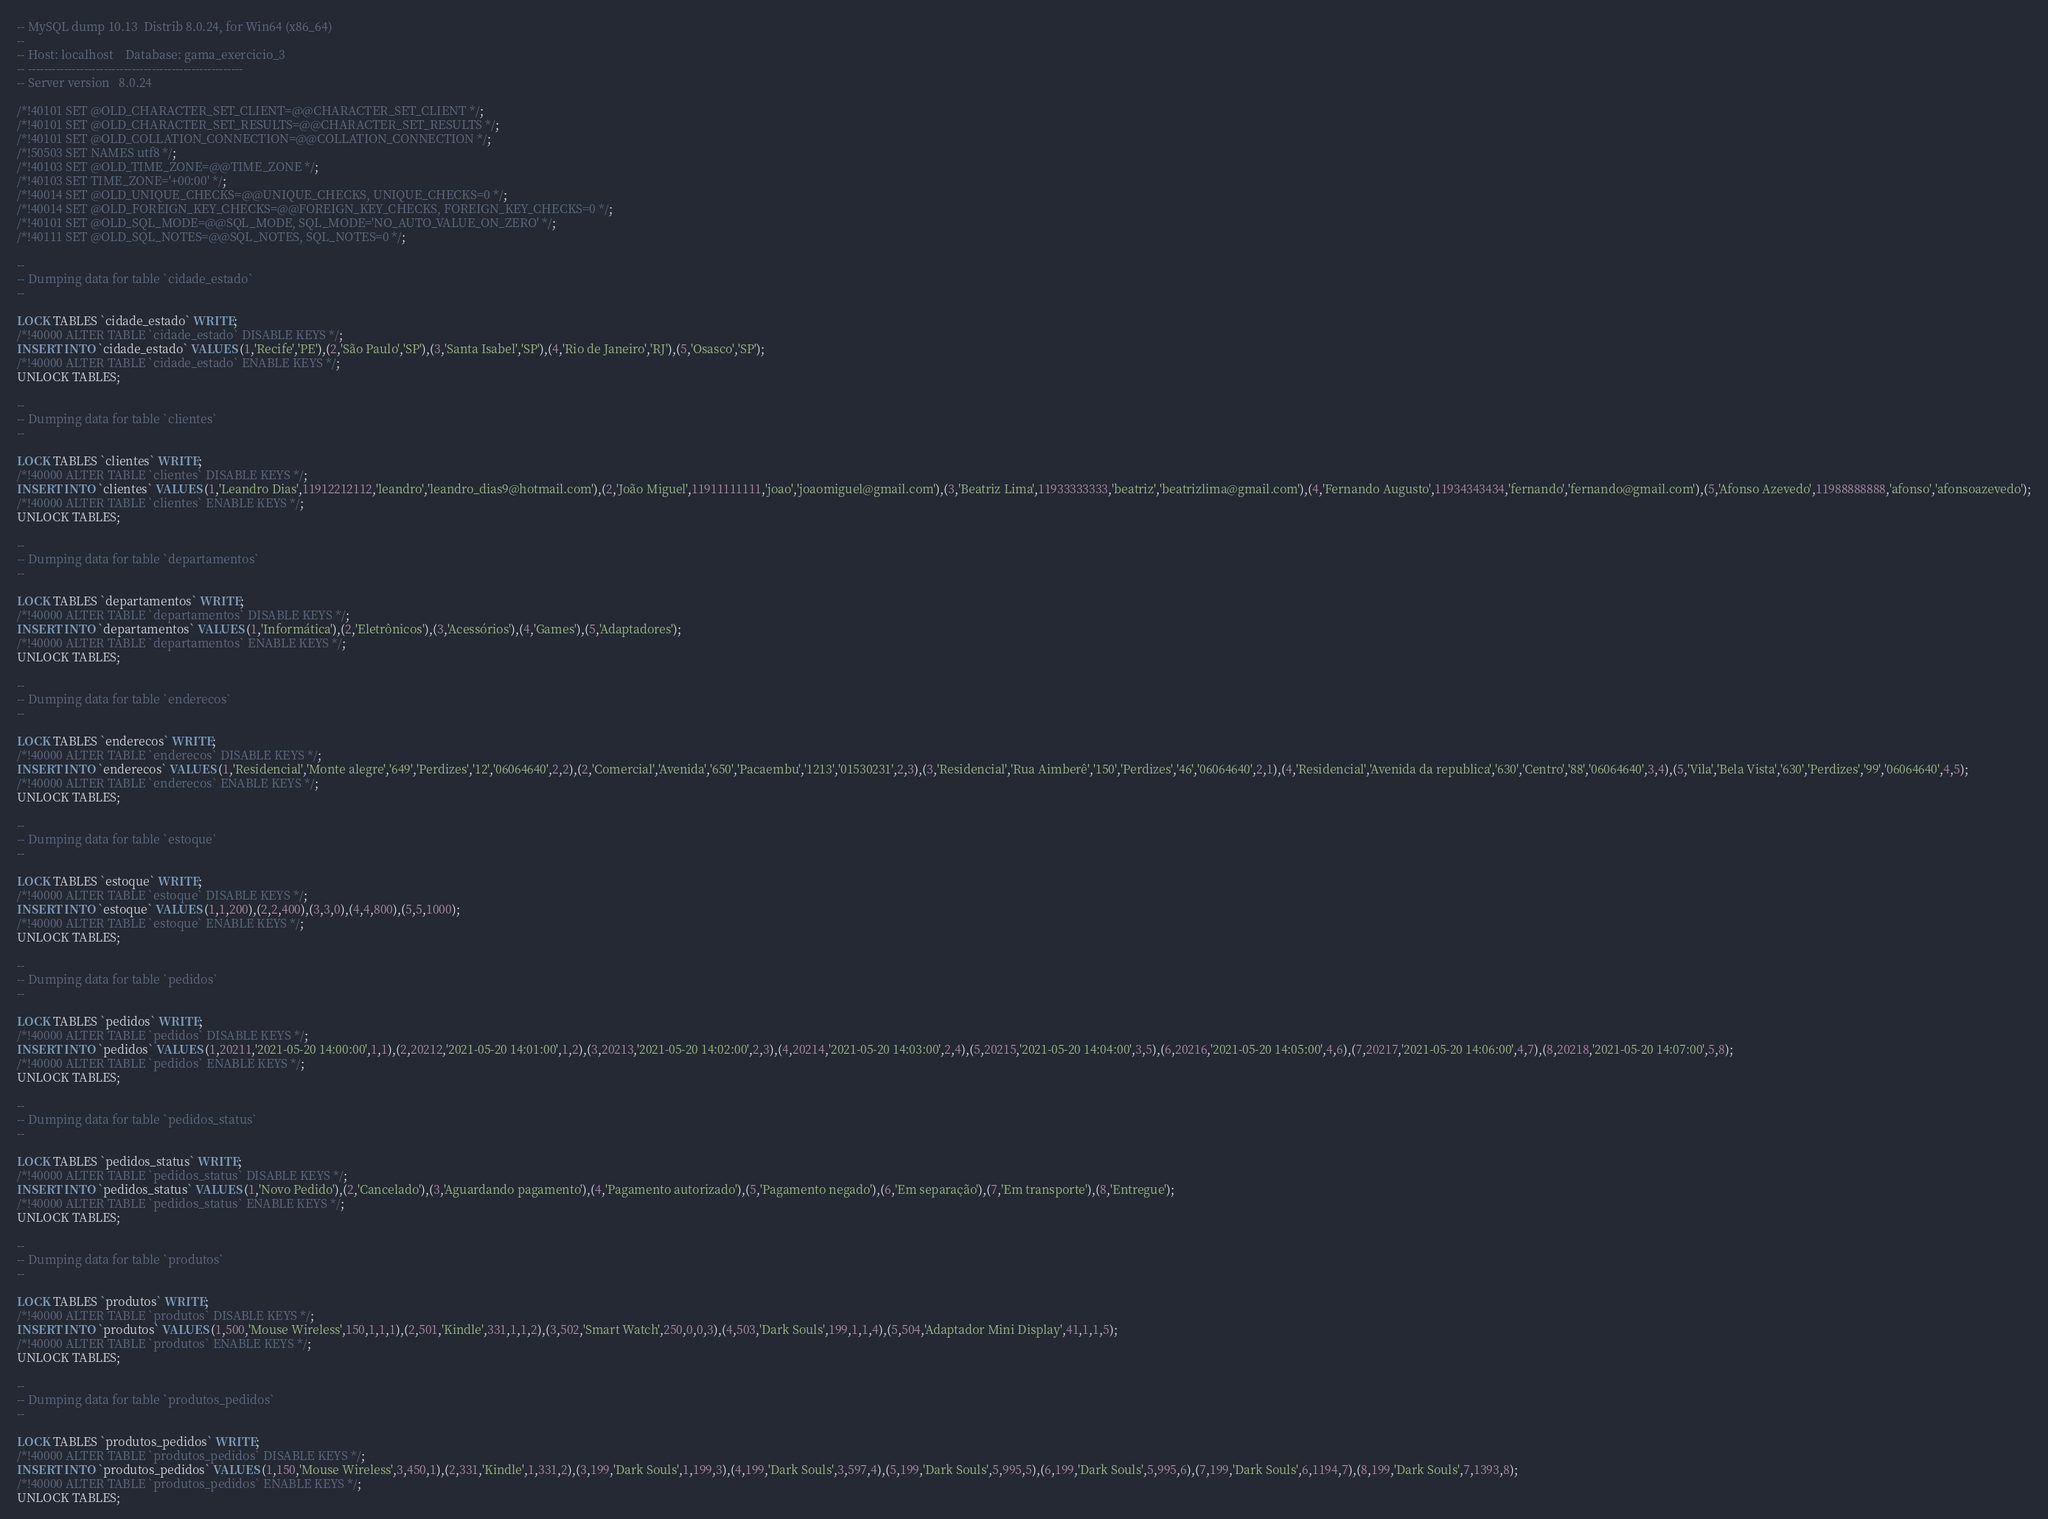<code> <loc_0><loc_0><loc_500><loc_500><_SQL_>-- MySQL dump 10.13  Distrib 8.0.24, for Win64 (x86_64)
--
-- Host: localhost    Database: gama_exercicio_3
-- ------------------------------------------------------
-- Server version	8.0.24

/*!40101 SET @OLD_CHARACTER_SET_CLIENT=@@CHARACTER_SET_CLIENT */;
/*!40101 SET @OLD_CHARACTER_SET_RESULTS=@@CHARACTER_SET_RESULTS */;
/*!40101 SET @OLD_COLLATION_CONNECTION=@@COLLATION_CONNECTION */;
/*!50503 SET NAMES utf8 */;
/*!40103 SET @OLD_TIME_ZONE=@@TIME_ZONE */;
/*!40103 SET TIME_ZONE='+00:00' */;
/*!40014 SET @OLD_UNIQUE_CHECKS=@@UNIQUE_CHECKS, UNIQUE_CHECKS=0 */;
/*!40014 SET @OLD_FOREIGN_KEY_CHECKS=@@FOREIGN_KEY_CHECKS, FOREIGN_KEY_CHECKS=0 */;
/*!40101 SET @OLD_SQL_MODE=@@SQL_MODE, SQL_MODE='NO_AUTO_VALUE_ON_ZERO' */;
/*!40111 SET @OLD_SQL_NOTES=@@SQL_NOTES, SQL_NOTES=0 */;

--
-- Dumping data for table `cidade_estado`
--

LOCK TABLES `cidade_estado` WRITE;
/*!40000 ALTER TABLE `cidade_estado` DISABLE KEYS */;
INSERT INTO `cidade_estado` VALUES (1,'Recife','PE'),(2,'São Paulo','SP'),(3,'Santa Isabel','SP'),(4,'Rio de Janeiro','RJ'),(5,'Osasco','SP');
/*!40000 ALTER TABLE `cidade_estado` ENABLE KEYS */;
UNLOCK TABLES;

--
-- Dumping data for table `clientes`
--

LOCK TABLES `clientes` WRITE;
/*!40000 ALTER TABLE `clientes` DISABLE KEYS */;
INSERT INTO `clientes` VALUES (1,'Leandro Dias',11912212112,'leandro','leandro_dias9@hotmail.com'),(2,'João Miguel',11911111111,'joao','joaomiguel@gmail.com'),(3,'Beatriz Lima',11933333333,'beatriz','beatrizlima@gmail.com'),(4,'Fernando Augusto',11934343434,'fernando','fernando@gmail.com'),(5,'Afonso Azevedo',11988888888,'afonso','afonsoazevedo');
/*!40000 ALTER TABLE `clientes` ENABLE KEYS */;
UNLOCK TABLES;

--
-- Dumping data for table `departamentos`
--

LOCK TABLES `departamentos` WRITE;
/*!40000 ALTER TABLE `departamentos` DISABLE KEYS */;
INSERT INTO `departamentos` VALUES (1,'Informática'),(2,'Eletrônicos'),(3,'Acessórios'),(4,'Games'),(5,'Adaptadores');
/*!40000 ALTER TABLE `departamentos` ENABLE KEYS */;
UNLOCK TABLES;

--
-- Dumping data for table `enderecos`
--

LOCK TABLES `enderecos` WRITE;
/*!40000 ALTER TABLE `enderecos` DISABLE KEYS */;
INSERT INTO `enderecos` VALUES (1,'Residencial','Monte alegre','649','Perdizes','12','06064640',2,2),(2,'Comercial','Avenida','650','Pacaembu','1213','01530231',2,3),(3,'Residencial','Rua Aimberê','150','Perdizes','46','06064640',2,1),(4,'Residencial','Avenida da republica','630','Centro','88','06064640',3,4),(5,'Vila','Bela Vista','630','Perdizes','99','06064640',4,5);
/*!40000 ALTER TABLE `enderecos` ENABLE KEYS */;
UNLOCK TABLES;

--
-- Dumping data for table `estoque`
--

LOCK TABLES `estoque` WRITE;
/*!40000 ALTER TABLE `estoque` DISABLE KEYS */;
INSERT INTO `estoque` VALUES (1,1,200),(2,2,400),(3,3,0),(4,4,800),(5,5,1000);
/*!40000 ALTER TABLE `estoque` ENABLE KEYS */;
UNLOCK TABLES;

--
-- Dumping data for table `pedidos`
--

LOCK TABLES `pedidos` WRITE;
/*!40000 ALTER TABLE `pedidos` DISABLE KEYS */;
INSERT INTO `pedidos` VALUES (1,20211,'2021-05-20 14:00:00',1,1),(2,20212,'2021-05-20 14:01:00',1,2),(3,20213,'2021-05-20 14:02:00',2,3),(4,20214,'2021-05-20 14:03:00',2,4),(5,20215,'2021-05-20 14:04:00',3,5),(6,20216,'2021-05-20 14:05:00',4,6),(7,20217,'2021-05-20 14:06:00',4,7),(8,20218,'2021-05-20 14:07:00',5,8);
/*!40000 ALTER TABLE `pedidos` ENABLE KEYS */;
UNLOCK TABLES;

--
-- Dumping data for table `pedidos_status`
--

LOCK TABLES `pedidos_status` WRITE;
/*!40000 ALTER TABLE `pedidos_status` DISABLE KEYS */;
INSERT INTO `pedidos_status` VALUES (1,'Novo Pedido'),(2,'Cancelado'),(3,'Aguardando pagamento'),(4,'Pagamento autorizado'),(5,'Pagamento negado'),(6,'Em separação'),(7,'Em transporte'),(8,'Entregue');
/*!40000 ALTER TABLE `pedidos_status` ENABLE KEYS */;
UNLOCK TABLES;

--
-- Dumping data for table `produtos`
--

LOCK TABLES `produtos` WRITE;
/*!40000 ALTER TABLE `produtos` DISABLE KEYS */;
INSERT INTO `produtos` VALUES (1,500,'Mouse Wireless',150,1,1,1),(2,501,'Kindle',331,1,1,2),(3,502,'Smart Watch',250,0,0,3),(4,503,'Dark Souls',199,1,1,4),(5,504,'Adaptador Mini Display',41,1,1,5);
/*!40000 ALTER TABLE `produtos` ENABLE KEYS */;
UNLOCK TABLES;

--
-- Dumping data for table `produtos_pedidos`
--

LOCK TABLES `produtos_pedidos` WRITE;
/*!40000 ALTER TABLE `produtos_pedidos` DISABLE KEYS */;
INSERT INTO `produtos_pedidos` VALUES (1,150,'Mouse Wireless',3,450,1),(2,331,'Kindle',1,331,2),(3,199,'Dark Souls',1,199,3),(4,199,'Dark Souls',3,597,4),(5,199,'Dark Souls',5,995,5),(6,199,'Dark Souls',5,995,6),(7,199,'Dark Souls',6,1194,7),(8,199,'Dark Souls',7,1393,8);
/*!40000 ALTER TABLE `produtos_pedidos` ENABLE KEYS */;
UNLOCK TABLES;</code> 